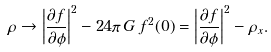Convert formula to latex. <formula><loc_0><loc_0><loc_500><loc_500>\rho \to \left | \frac { \partial f } { \partial \phi } \right | ^ { 2 } - 2 4 \pi \, G \, f ^ { 2 } ( 0 ) = \left | \frac { \partial f } { \partial \phi } \right | ^ { 2 } - \rho _ { x } .</formula> 